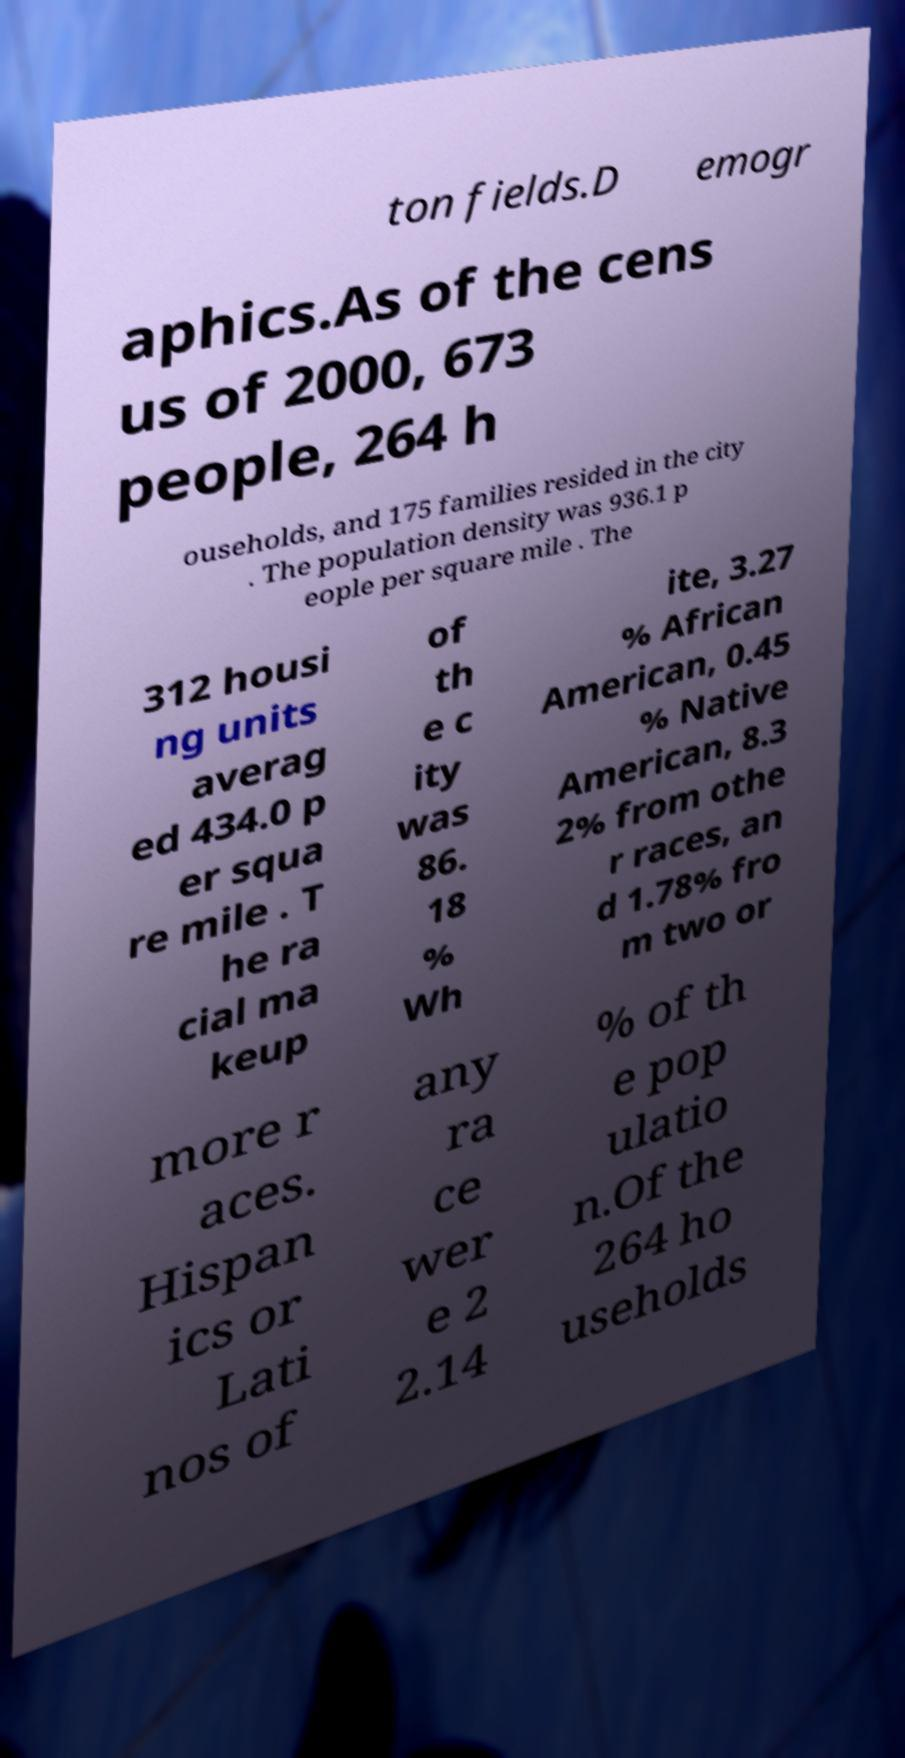I need the written content from this picture converted into text. Can you do that? ton fields.D emogr aphics.As of the cens us of 2000, 673 people, 264 h ouseholds, and 175 families resided in the city . The population density was 936.1 p eople per square mile . The 312 housi ng units averag ed 434.0 p er squa re mile . T he ra cial ma keup of th e c ity was 86. 18 % Wh ite, 3.27 % African American, 0.45 % Native American, 8.3 2% from othe r races, an d 1.78% fro m two or more r aces. Hispan ics or Lati nos of any ra ce wer e 2 2.14 % of th e pop ulatio n.Of the 264 ho useholds 